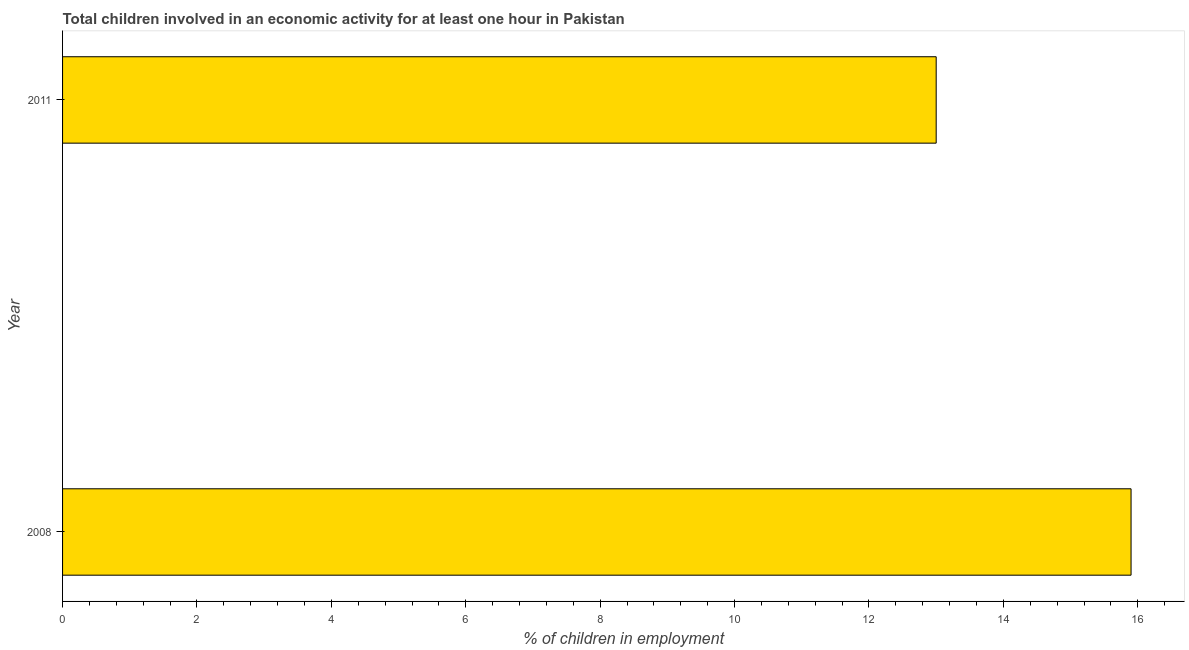Does the graph contain any zero values?
Your answer should be very brief. No. Does the graph contain grids?
Keep it short and to the point. No. What is the title of the graph?
Your answer should be very brief. Total children involved in an economic activity for at least one hour in Pakistan. What is the label or title of the X-axis?
Keep it short and to the point. % of children in employment. What is the percentage of children in employment in 2008?
Provide a succinct answer. 15.9. Across all years, what is the minimum percentage of children in employment?
Make the answer very short. 13. What is the sum of the percentage of children in employment?
Your response must be concise. 28.9. What is the difference between the percentage of children in employment in 2008 and 2011?
Your answer should be compact. 2.9. What is the average percentage of children in employment per year?
Your answer should be compact. 14.45. What is the median percentage of children in employment?
Provide a short and direct response. 14.45. In how many years, is the percentage of children in employment greater than 6 %?
Give a very brief answer. 2. What is the ratio of the percentage of children in employment in 2008 to that in 2011?
Ensure brevity in your answer.  1.22. In how many years, is the percentage of children in employment greater than the average percentage of children in employment taken over all years?
Your response must be concise. 1. Are all the bars in the graph horizontal?
Ensure brevity in your answer.  Yes. How many years are there in the graph?
Your response must be concise. 2. What is the difference between two consecutive major ticks on the X-axis?
Your answer should be very brief. 2. What is the % of children in employment of 2008?
Your answer should be very brief. 15.9. What is the difference between the % of children in employment in 2008 and 2011?
Your response must be concise. 2.9. What is the ratio of the % of children in employment in 2008 to that in 2011?
Make the answer very short. 1.22. 